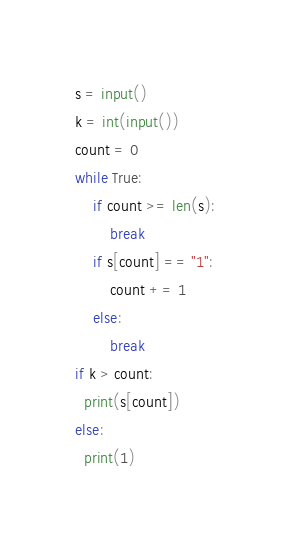<code> <loc_0><loc_0><loc_500><loc_500><_Python_>s = input()
k = int(input())
count = 0
while True:
    if count >= len(s):
        break
    if s[count] == "1":
        count += 1
    else:
        break
if k > count:
  print(s[count])
else:
  print(1)</code> 